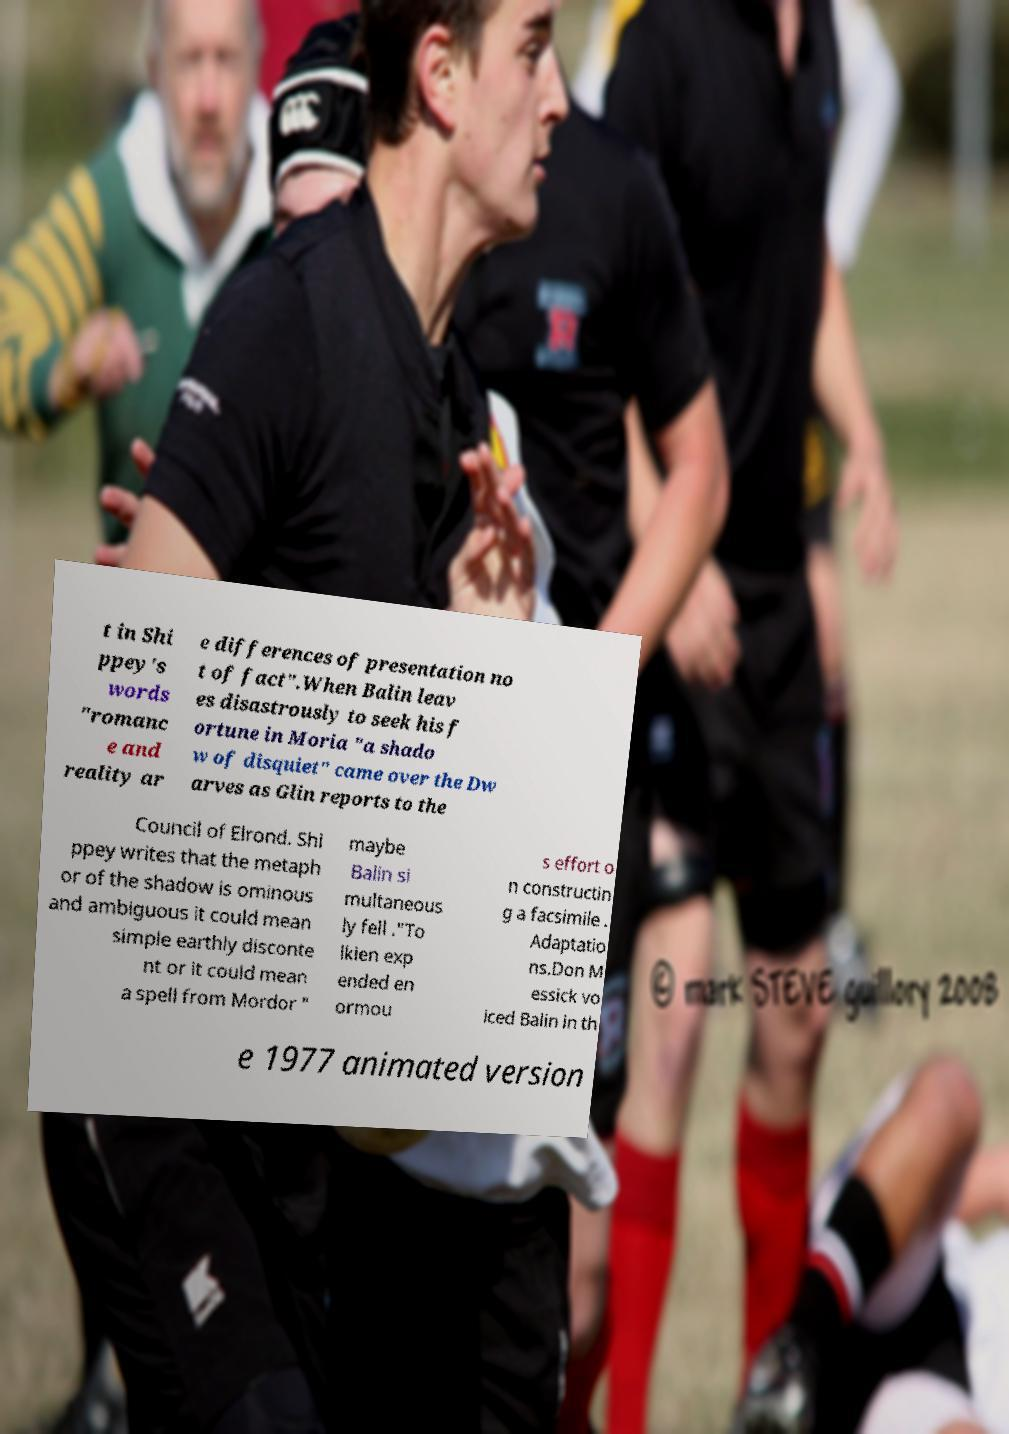Could you extract and type out the text from this image? t in Shi ppey's words "romanc e and reality ar e differences of presentation no t of fact".When Balin leav es disastrously to seek his f ortune in Moria "a shado w of disquiet" came over the Dw arves as Glin reports to the Council of Elrond. Shi ppey writes that the metaph or of the shadow is ominous and ambiguous it could mean simple earthly disconte nt or it could mean a spell from Mordor " maybe Balin si multaneous ly fell ."To lkien exp ended en ormou s effort o n constructin g a facsimile . Adaptatio ns.Don M essick vo iced Balin in th e 1977 animated version 